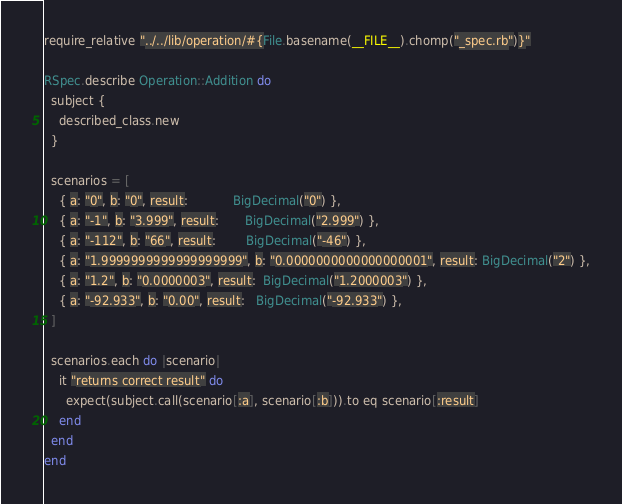<code> <loc_0><loc_0><loc_500><loc_500><_Ruby_>require_relative "../../lib/operation/#{File.basename(__FILE__).chomp("_spec.rb")}"

RSpec.describe Operation::Addition do
  subject {
    described_class.new
  }

  scenarios = [
    { a: "0", b: "0", result:            BigDecimal("0") },
    { a: "-1", b: "3.999", result:       BigDecimal("2.999") },
    { a: "-112", b: "66", result:        BigDecimal("-46") },
    { a: "1.9999999999999999999", b: "0.0000000000000000001", result: BigDecimal("2") },
    { a: "1.2", b: "0.0000003", result:  BigDecimal("1.2000003") },
    { a: "-92.933", b: "0.00", result:   BigDecimal("-92.933") },
  ]

  scenarios.each do |scenario|
    it "returns correct result" do
      expect(subject.call(scenario[:a], scenario[:b])).to eq scenario[:result]
    end
  end
end
</code> 